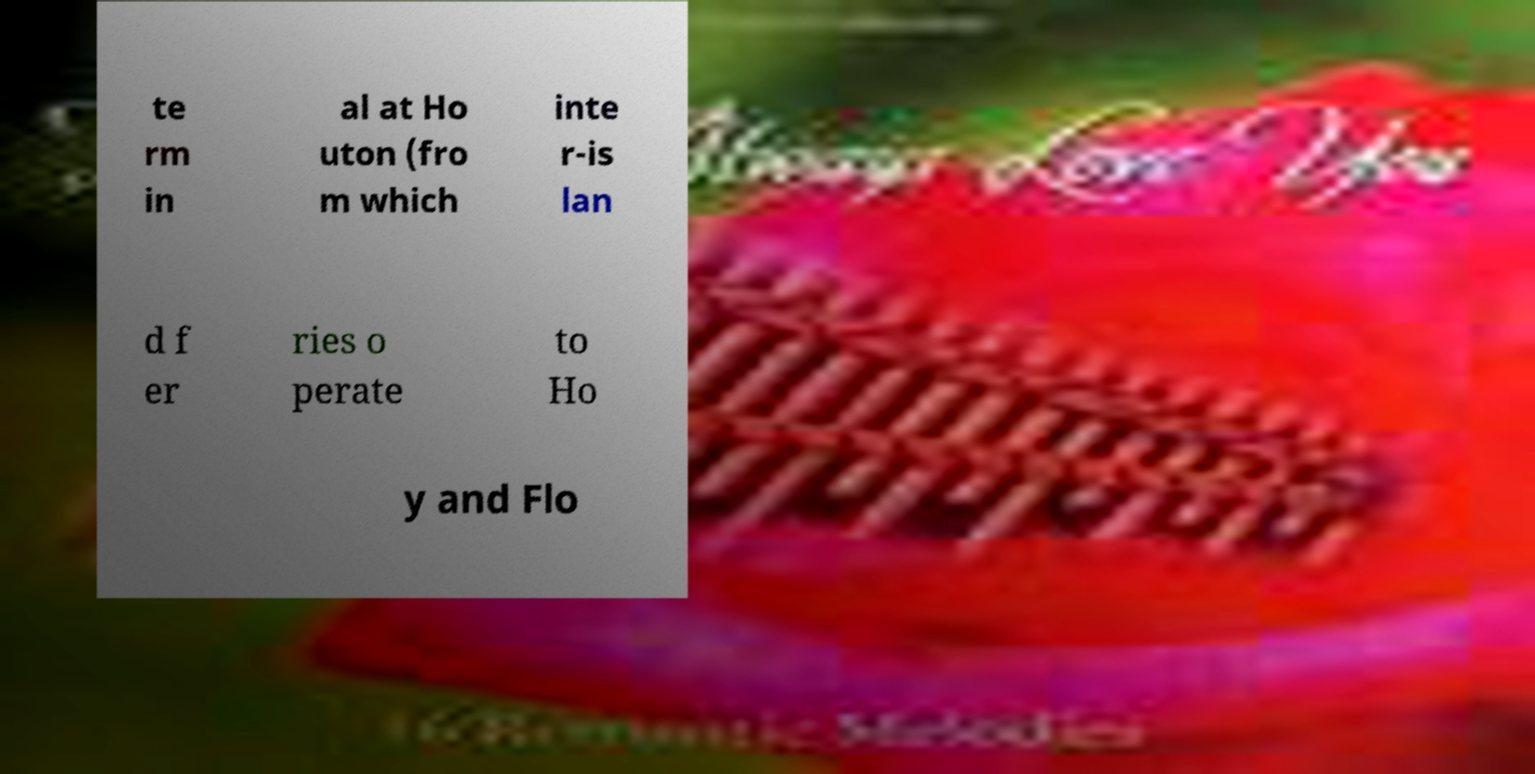Can you read and provide the text displayed in the image?This photo seems to have some interesting text. Can you extract and type it out for me? te rm in al at Ho uton (fro m which inte r-is lan d f er ries o perate to Ho y and Flo 